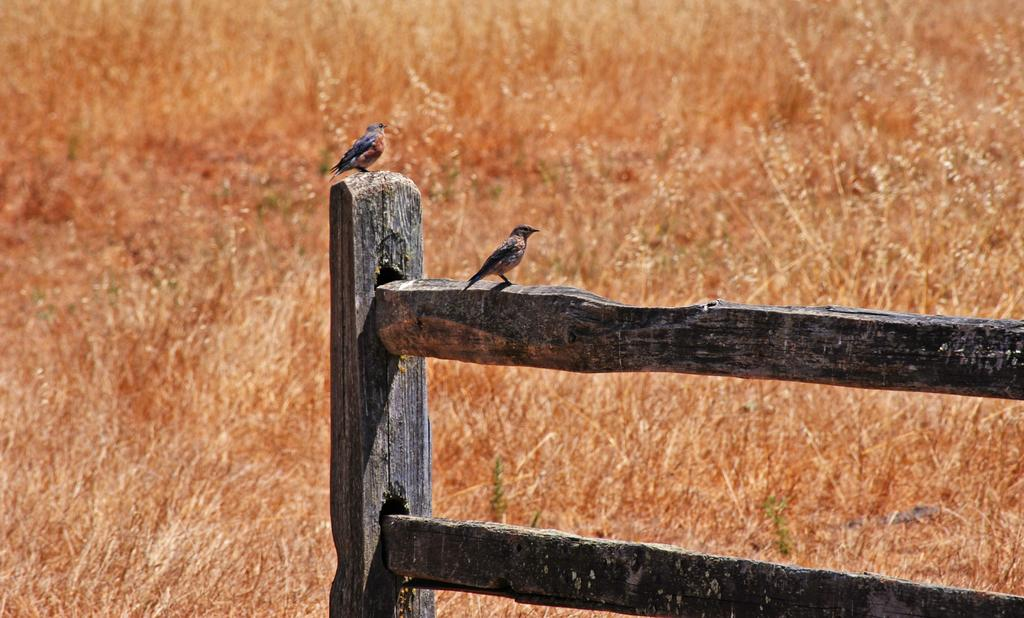How many birds are in the image? There are two birds in the image. Where are the birds located? The birds are on a wooden fence. What type of surface can be seen in the image? There is dry grass on the surface in the image. What is the chance of an ant being present in the image? There is no ant present in the image, so it is impossible to determine the chance of one being there. 